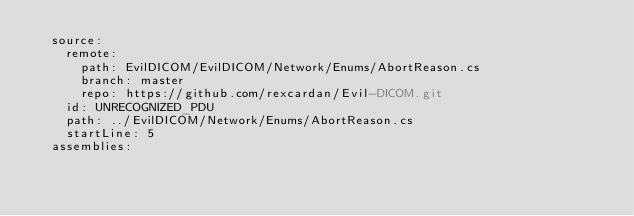<code> <loc_0><loc_0><loc_500><loc_500><_YAML_>  source:
    remote:
      path: EvilDICOM/EvilDICOM/Network/Enums/AbortReason.cs
      branch: master
      repo: https://github.com/rexcardan/Evil-DICOM.git
    id: UNRECOGNIZED_PDU
    path: ../EvilDICOM/Network/Enums/AbortReason.cs
    startLine: 5
  assemblies:</code> 